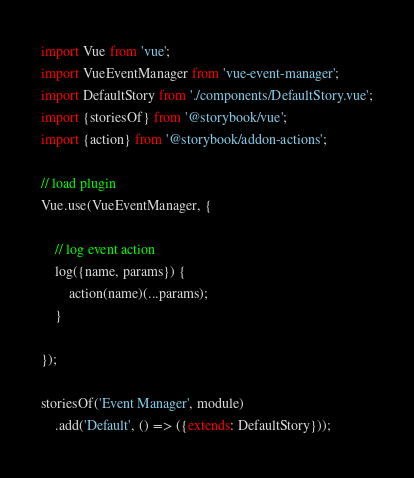Convert code to text. <code><loc_0><loc_0><loc_500><loc_500><_JavaScript_>import Vue from 'vue';
import VueEventManager from 'vue-event-manager';
import DefaultStory from './components/DefaultStory.vue';
import {storiesOf} from '@storybook/vue';
import {action} from '@storybook/addon-actions';

// load plugin
Vue.use(VueEventManager, {

    // log event action
    log({name, params}) {
        action(name)(...params);
    }

});

storiesOf('Event Manager', module)
    .add('Default', () => ({extends: DefaultStory}));
</code> 